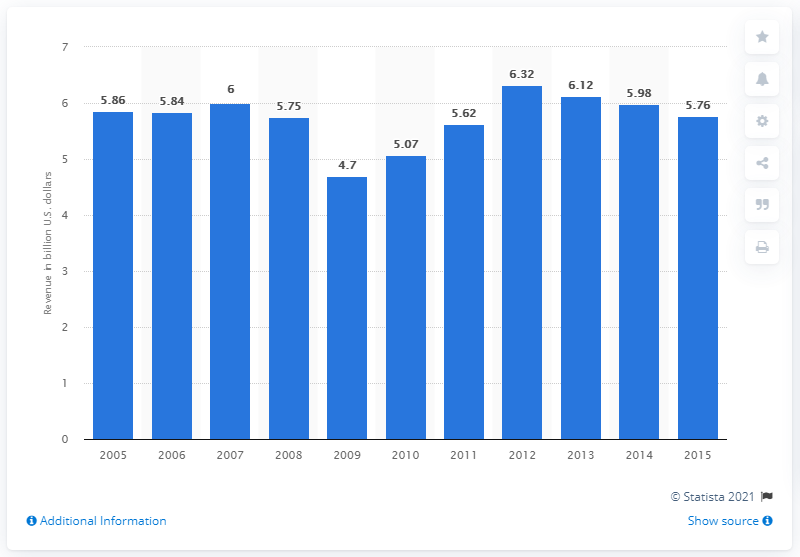Mention a couple of crucial points in this snapshot. In 2015, Starwood Hotels & Resorts generated approximately $5.76 billion in revenue. 